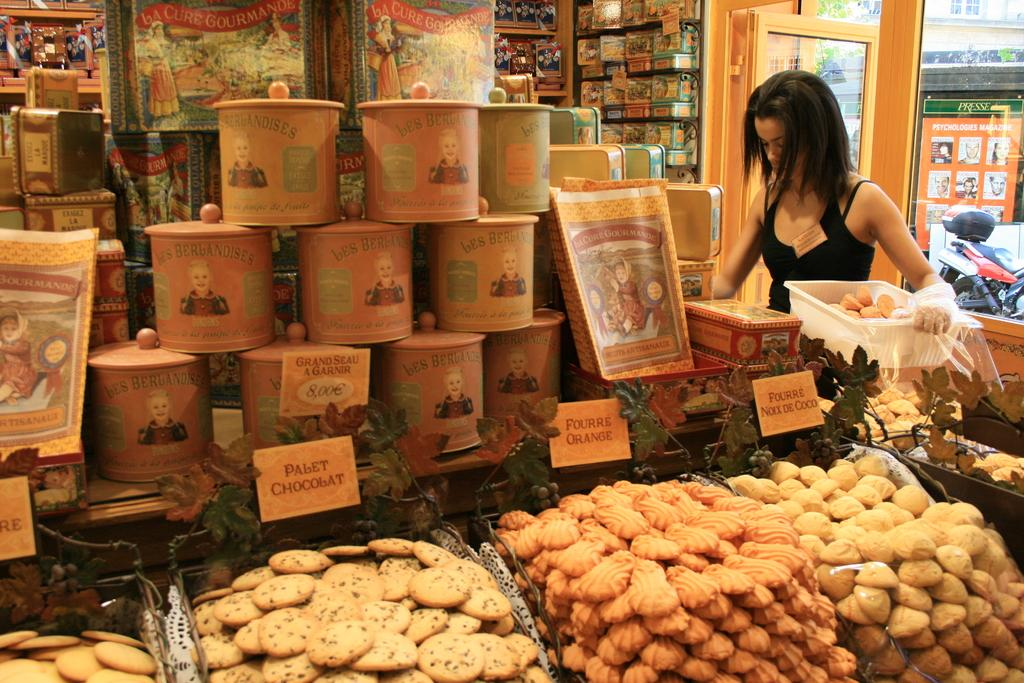<image>
Relay a brief, clear account of the picture shown. A woman in black stands in front of a display of bes Berlandises cookies 